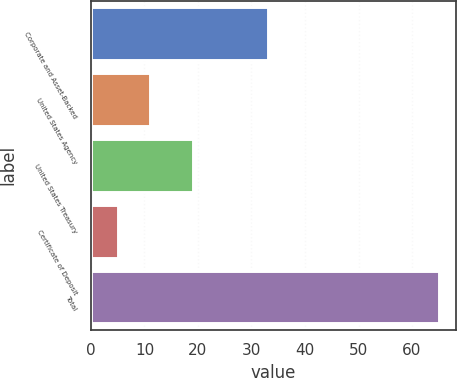<chart> <loc_0><loc_0><loc_500><loc_500><bar_chart><fcel>Corporate and Asset-Backed<fcel>United States Agency<fcel>United States Treasury<fcel>Certificate of Deposit<fcel>Total<nl><fcel>33<fcel>11<fcel>19<fcel>5<fcel>65<nl></chart> 